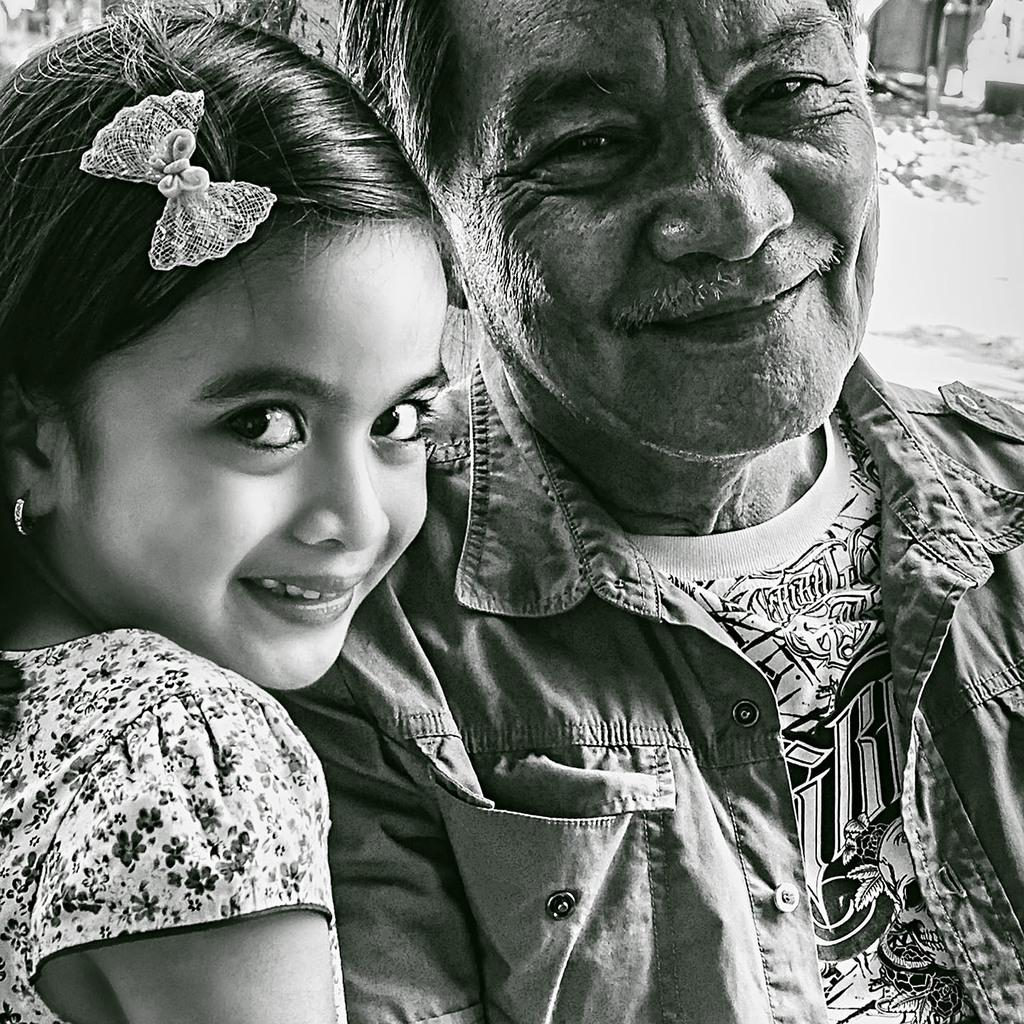Who is present in the image? There is a man and a child in the image. What are the man and the child wearing? The man and the child are both wearing clothes. What type of trail can be seen in the image? There is no trail present in the image. What company is associated with the oven in the image? There is no oven present in the image. 